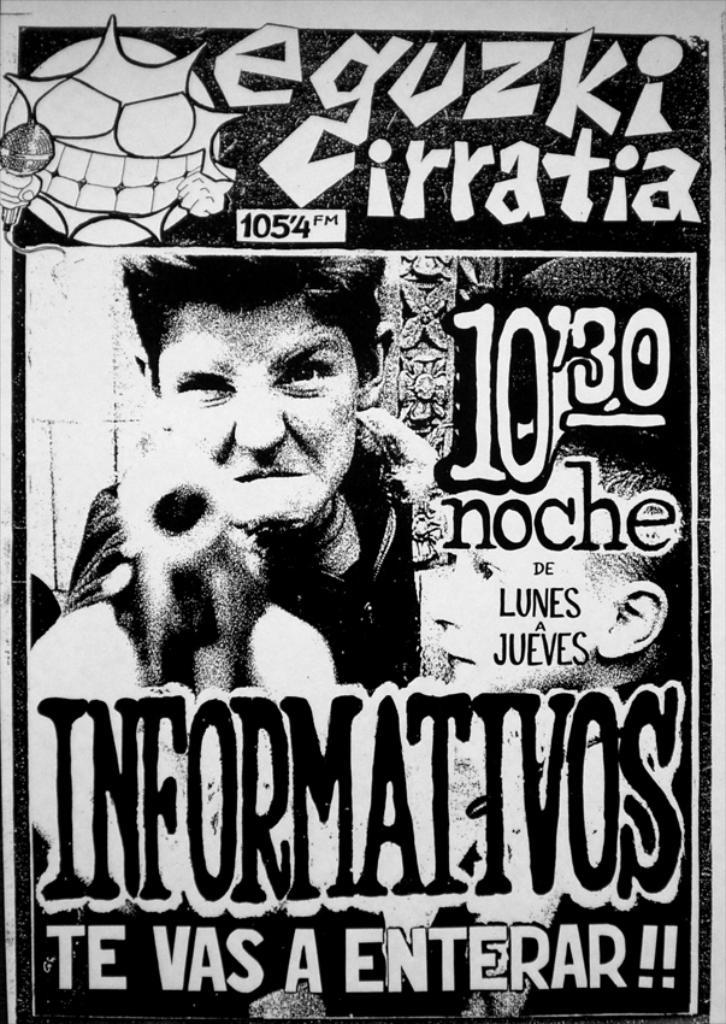What time does this take place?
Your answer should be very brief. 10:30. What does the text in white say at the bottom?
Ensure brevity in your answer.  Te vas a enterar. 